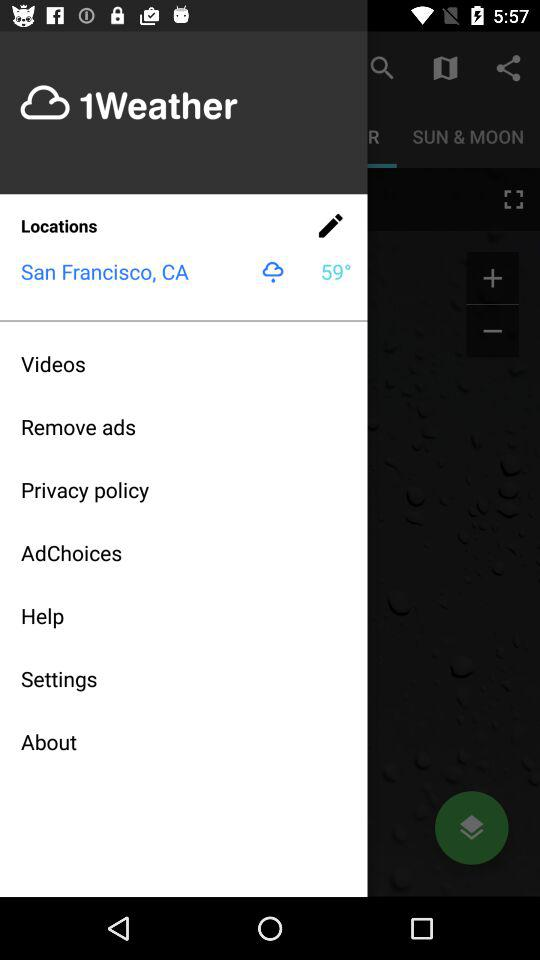What is the name of the application? The name of the application is "1Weather". 